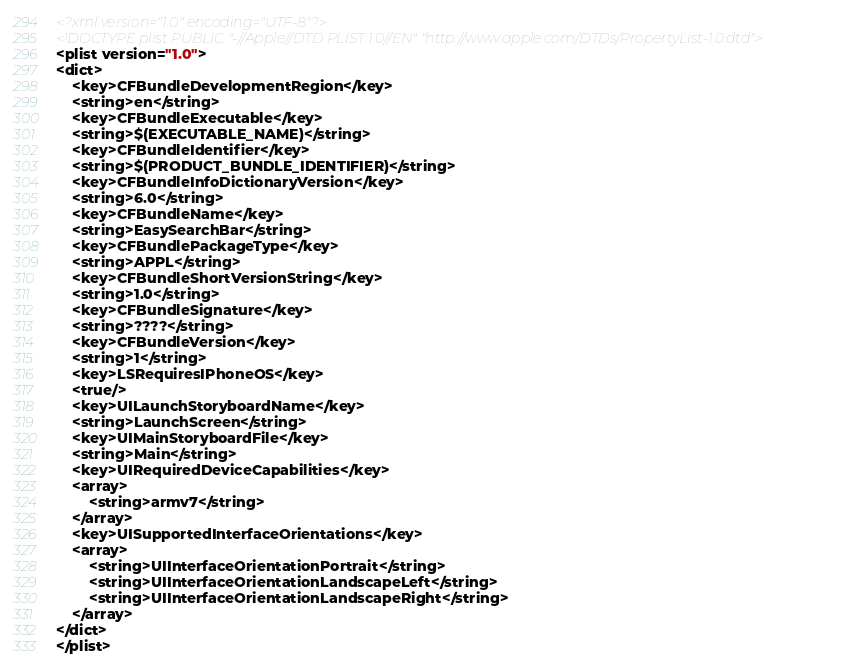<code> <loc_0><loc_0><loc_500><loc_500><_XML_><?xml version="1.0" encoding="UTF-8"?>
<!DOCTYPE plist PUBLIC "-//Apple//DTD PLIST 1.0//EN" "http://www.apple.com/DTDs/PropertyList-1.0.dtd">
<plist version="1.0">
<dict>
	<key>CFBundleDevelopmentRegion</key>
	<string>en</string>
	<key>CFBundleExecutable</key>
	<string>$(EXECUTABLE_NAME)</string>
	<key>CFBundleIdentifier</key>
	<string>$(PRODUCT_BUNDLE_IDENTIFIER)</string>
	<key>CFBundleInfoDictionaryVersion</key>
	<string>6.0</string>
	<key>CFBundleName</key>
	<string>EasySearchBar</string>
	<key>CFBundlePackageType</key>
	<string>APPL</string>
	<key>CFBundleShortVersionString</key>
	<string>1.0</string>
	<key>CFBundleSignature</key>
	<string>????</string>
	<key>CFBundleVersion</key>
	<string>1</string>
	<key>LSRequiresIPhoneOS</key>
	<true/>
	<key>UILaunchStoryboardName</key>
	<string>LaunchScreen</string>
	<key>UIMainStoryboardFile</key>
	<string>Main</string>
	<key>UIRequiredDeviceCapabilities</key>
	<array>
		<string>armv7</string>
	</array>
	<key>UISupportedInterfaceOrientations</key>
	<array>
		<string>UIInterfaceOrientationPortrait</string>
		<string>UIInterfaceOrientationLandscapeLeft</string>
		<string>UIInterfaceOrientationLandscapeRight</string>
	</array>
</dict>
</plist>
</code> 